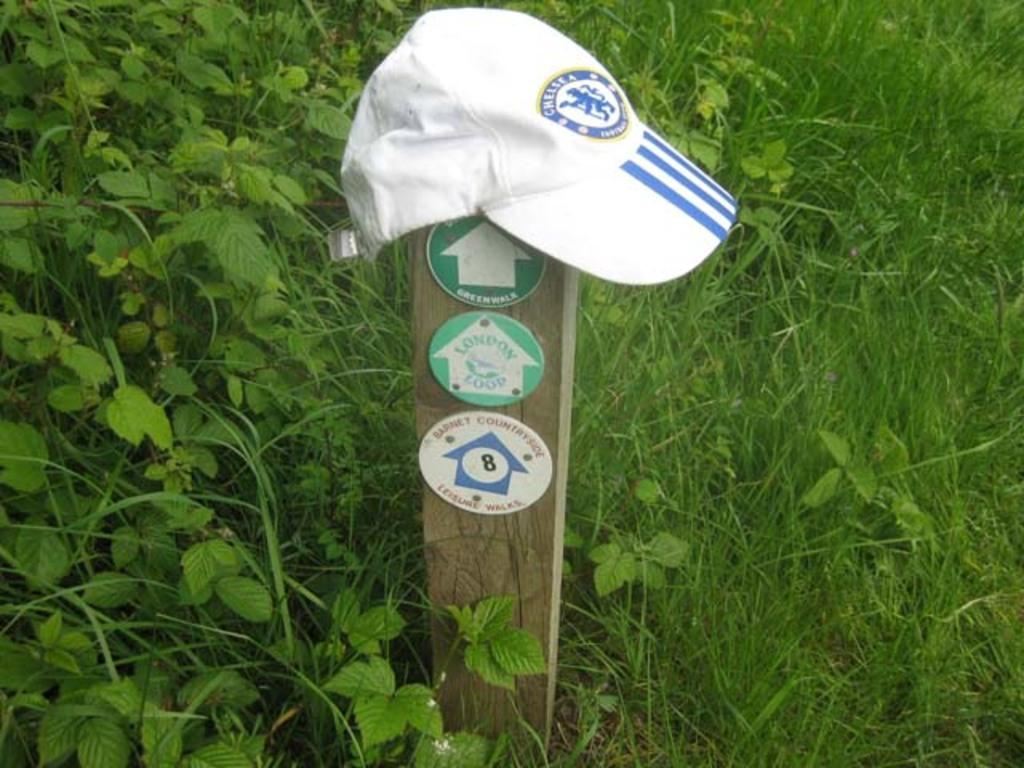What type of plants can be seen in the image? There are green color plants in the image. Can you describe any other objects in the image? Yes, there is a cap in the image. What arithmetic problem is being solved by the farmer in the image? There is no farmer or arithmetic problem present in the image. 